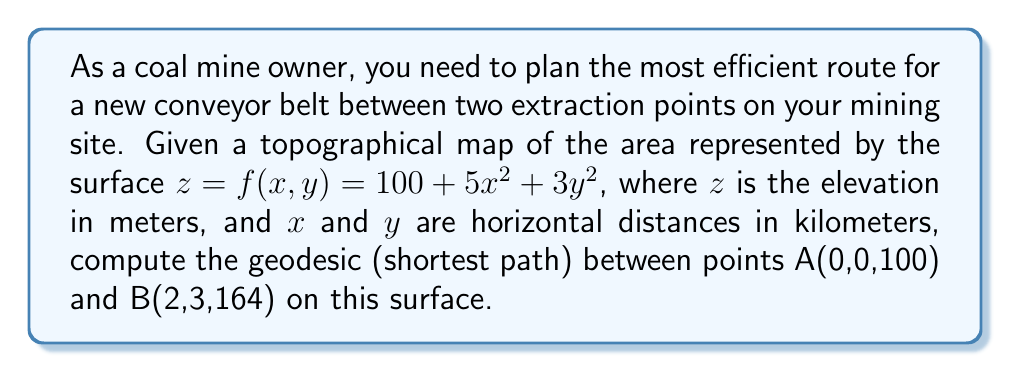Could you help me with this problem? To find the geodesic between two points on a surface, we need to solve the geodesic equations. For a surface given by $z = f(x,y)$, the geodesic equations are:

$$\frac{d^2x}{ds^2} + \Gamma^x_{xx}\left(\frac{dx}{ds}\right)^2 + 2\Gamma^x_{xy}\frac{dx}{ds}\frac{dy}{ds} + \Gamma^x_{yy}\left(\frac{dy}{ds}\right)^2 = 0$$
$$\frac{d^2y}{ds^2} + \Gamma^y_{xx}\left(\frac{dx}{ds}\right)^2 + 2\Gamma^y_{xy}\frac{dx}{ds}\frac{dy}{ds} + \Gamma^y_{yy}\left(\frac{dy}{ds}\right)^2 = 0$$

Where $\Gamma^i_{jk}$ are the Christoffel symbols of the second kind.

Step 1: Calculate the metric tensor components:
$g_{11} = 1 + f_x^2 = 1 + (10x)^2 = 1 + 100x^2$
$g_{12} = g_{21} = f_xf_y = (10x)(6y) = 60xy$
$g_{22} = 1 + f_y^2 = 1 + (6y)^2 = 1 + 36y^2$

Step 2: Calculate the Christoffel symbols:
$\Gamma^x_{xx} = \frac{100x}{1+100x^2+36y^2}$
$\Gamma^x_{xy} = \Gamma^x_{yx} = \frac{30y}{1+100x^2+36y^2}$
$\Gamma^x_{yy} = -\frac{60xy}{1+100x^2+36y^2}$
$\Gamma^y_{xx} = -\frac{60xy}{1+100x^2+36y^2}$
$\Gamma^y_{xy} = \Gamma^y_{yx} = \frac{50x}{1+100x^2+36y^2}$
$\Gamma^y_{yy} = \frac{36y}{1+100x^2+36y^2}$

Step 3: Solve the geodesic equations numerically with boundary conditions:
$x(0) = 0, y(0) = 0, x(1) = 2, y(1) = 3$

Using a numerical method (e.g., shooting method or relaxation method), we can solve these equations to find the geodesic path.

Step 4: Calculate the length of the geodesic:
The length of the geodesic is given by:
$$L = \int_0^1 \sqrt{g_{11}\left(\frac{dx}{ds}\right)^2 + 2g_{12}\frac{dx}{ds}\frac{dy}{ds} + g_{22}\left(\frac{dy}{ds}\right)^2} ds$$

Using the numerical solution from Step 3, we can approximate this integral.
Answer: $L \approx 5.32$ km 